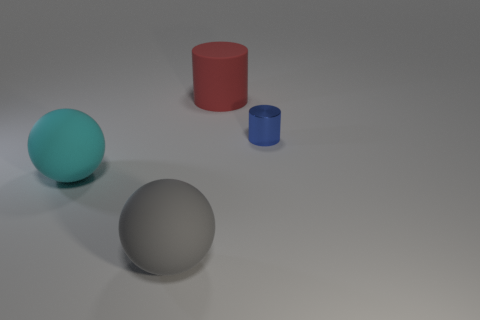Add 2 large purple matte objects. How many objects exist? 6 Subtract all blue cylinders. How many cylinders are left? 1 Subtract all purple cylinders. How many green spheres are left? 0 Subtract 0 yellow cubes. How many objects are left? 4 Subtract 1 cylinders. How many cylinders are left? 1 Subtract all green cylinders. Subtract all brown cubes. How many cylinders are left? 2 Subtract all metallic things. Subtract all big red rubber cylinders. How many objects are left? 2 Add 2 cylinders. How many cylinders are left? 4 Add 4 cyan objects. How many cyan objects exist? 5 